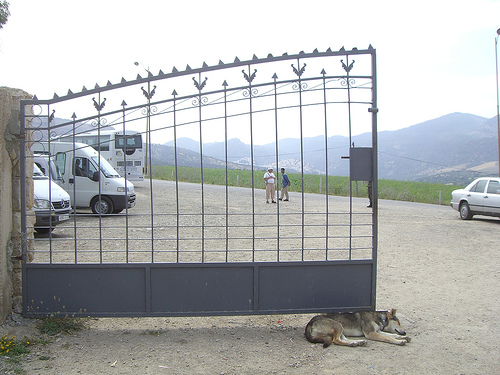<image>
Is the gate behind the van? No. The gate is not behind the van. From this viewpoint, the gate appears to be positioned elsewhere in the scene. 